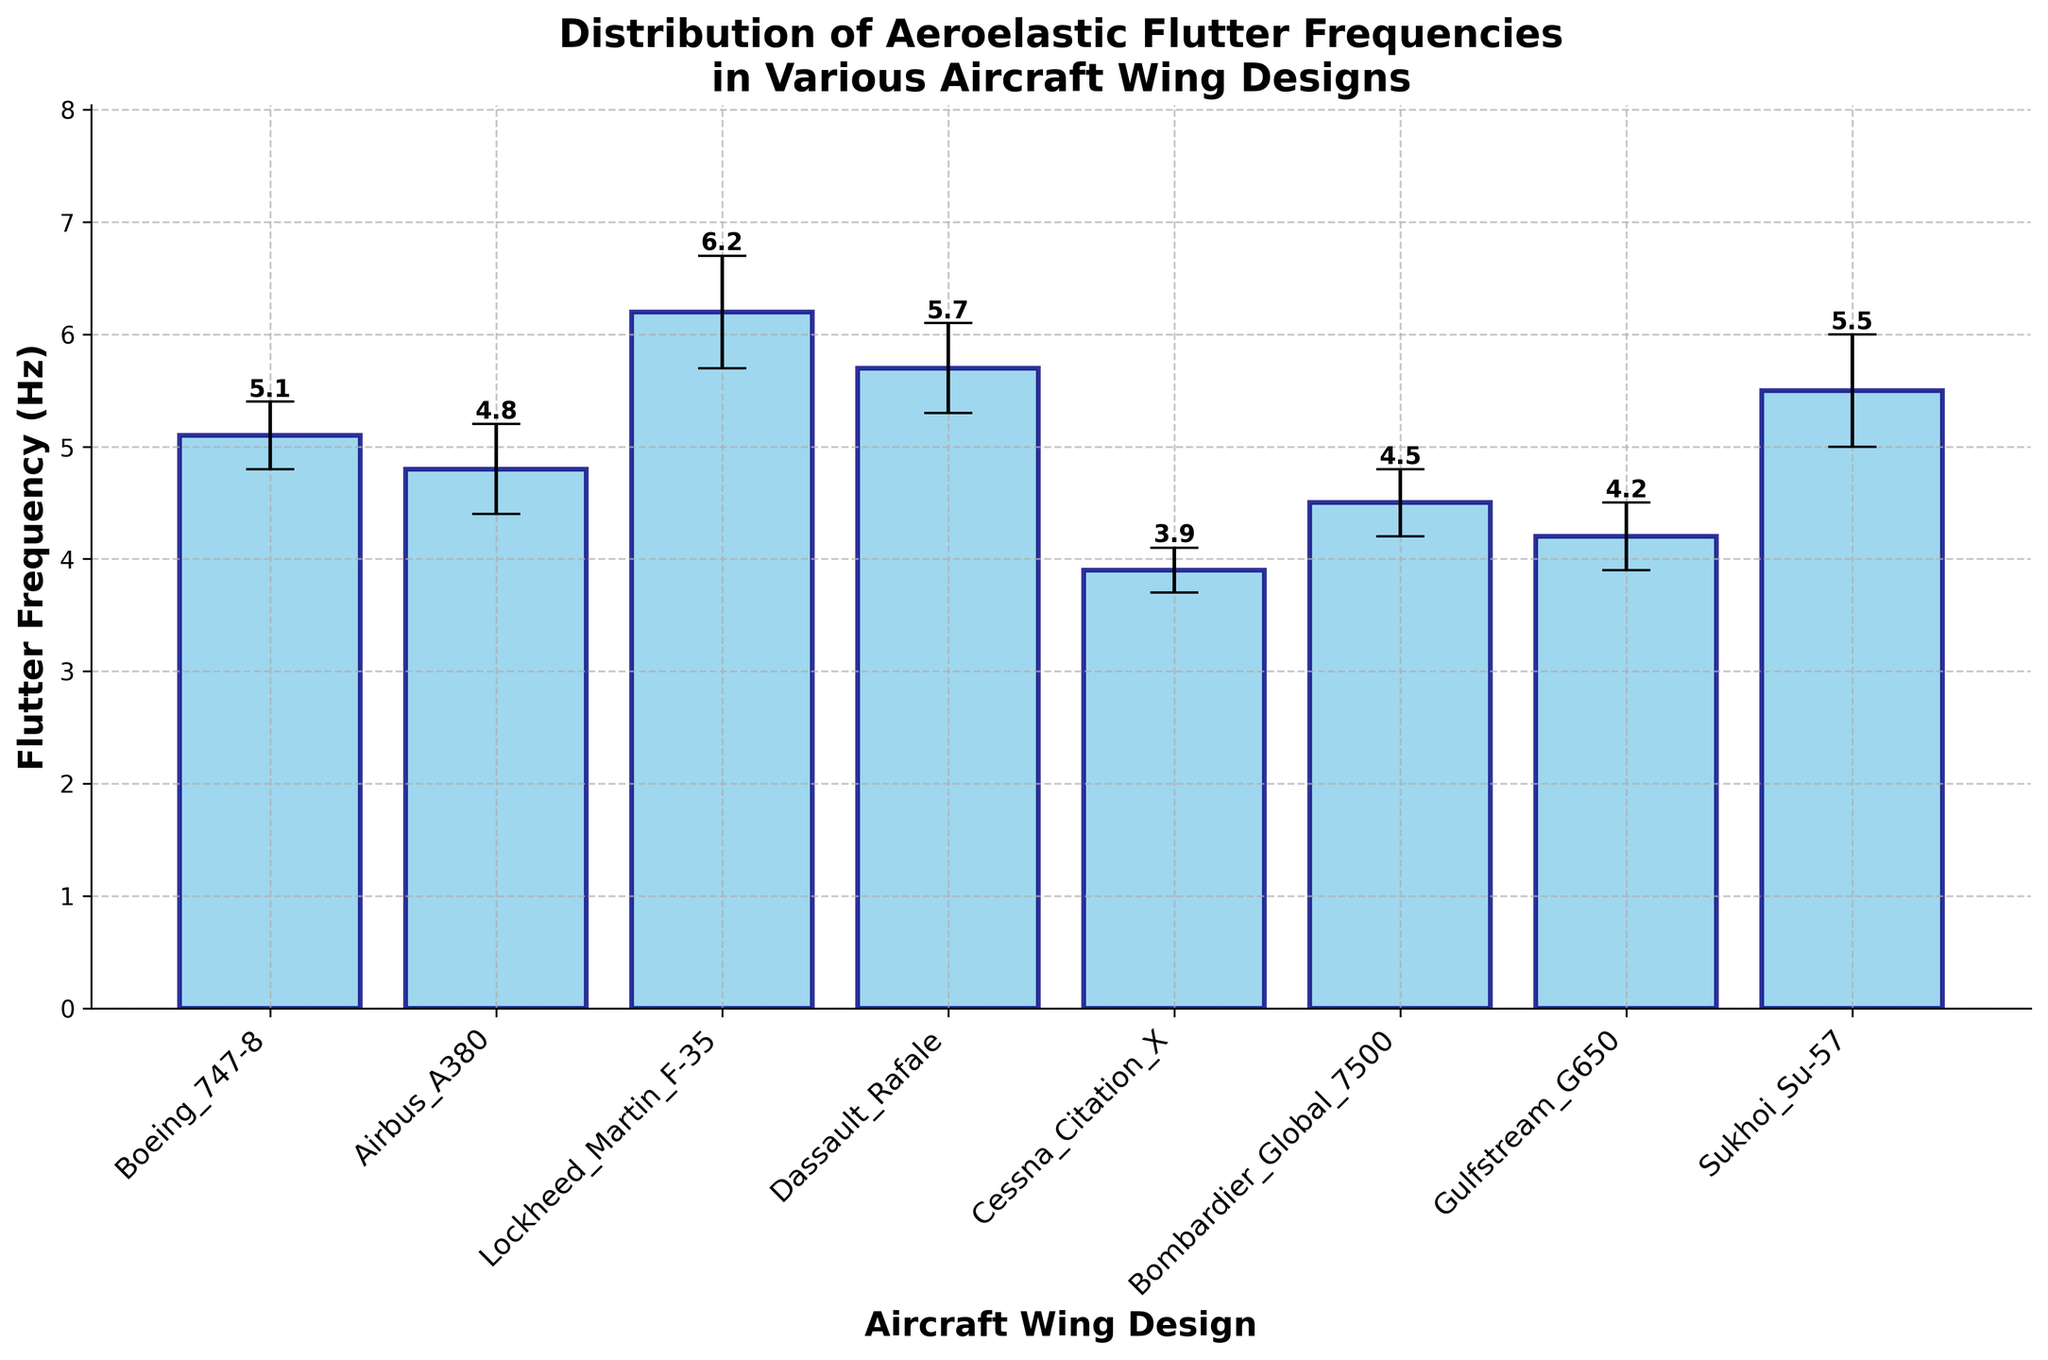What is the title of the figure? The title is given at the top of the figure. It is the most prominent text.
Answer: Distribution of Aeroelastic Flutter Frequencies in Various Aircraft Wing Designs How many aircraft wing designs are compared in the figure? Count the number of distinct bars or labels on the x-axis.
Answer: 8 Which aircraft wing design has the highest flutter frequency? Look for the tallest bar in the plot and check its label.
Answer: Lockheed Martin F-35 What is the mean flutter frequency of the Boeing 747-8? Read the value from the top of the bar labeled "Boeing 747-8".
Answer: 5.1 Hz What is the difference in mean flutter frequency between the Lockheed Martin F-35 and the Cessna Citation X? Subtract the mean flutter frequency of Cessna Citation X from that of Lockheed Martin F-35.
Answer: 2.3 Hz What is the range of the error bars for the Airbus A380? The error bars show the standard deviation, which is added and subtracted from the mean. Here, it's ±0.4 Hz for Airbus A380.
Answer: ±0.4 Hz How do the error bars of the Bombardier Global 7500 compare with those of the Gulfstream G650? Observe the length of the error bars for both datasets. Both bars' error lengths can be compared visually.
Answer: They are the same length Which aircraft wing design has a mean flutter frequency closest to 5 Hz? Identify the bar whose height is closest to the 5 Hz mark.
Answer: Boeing 747-8 What are the lower and upper bounds of the flutter frequency for the Dassault Rafale? Calculate the lower bound as mean minus the error and the upper bound as mean plus the error. For Dassault Rafale, it's 5.7 - 0.4 = 5.3 Hz and 5.7 + 0.4 = 6.1 Hz.
Answer: 5.3 Hz and 6.1 Hz How does the mean flutter frequency of the Sukhoi Su-57 compare to that of the Dassault Rafale? Find and compare the heights of the bars corresponding to these two aircraft designs.
Answer: The Sukhoi Su-57 is lower 